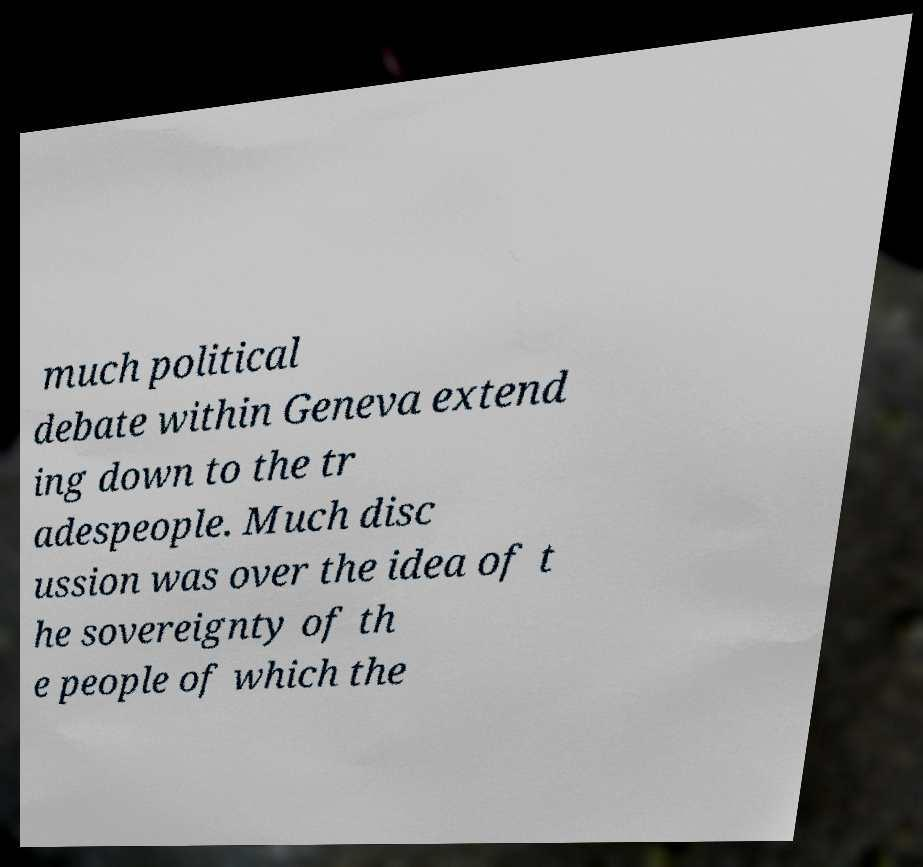There's text embedded in this image that I need extracted. Can you transcribe it verbatim? much political debate within Geneva extend ing down to the tr adespeople. Much disc ussion was over the idea of t he sovereignty of th e people of which the 